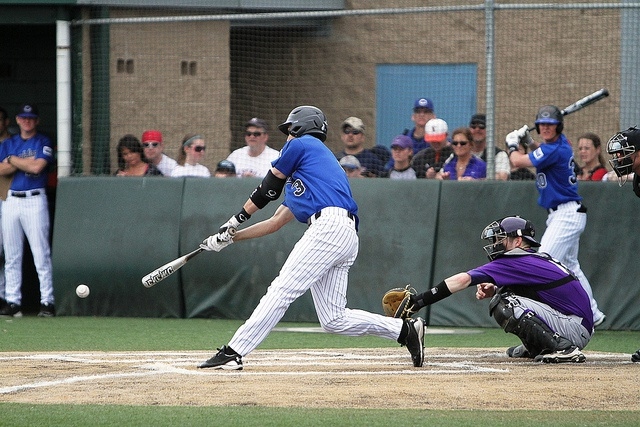Describe the objects in this image and their specific colors. I can see people in black, white, darkgray, and gray tones, people in black, gray, navy, and lightgray tones, people in black, gray, and navy tones, people in black, lavender, navy, and gray tones, and people in black, lavender, darkgray, and navy tones in this image. 